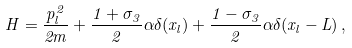Convert formula to latex. <formula><loc_0><loc_0><loc_500><loc_500>H = \frac { p _ { l } ^ { 2 } } { 2 m } + \frac { 1 + \sigma _ { 3 } } { 2 } \alpha \delta ( x _ { l } ) + \frac { 1 - \sigma _ { 3 } } { 2 } \alpha \delta ( x _ { l } - L ) \, ,</formula> 